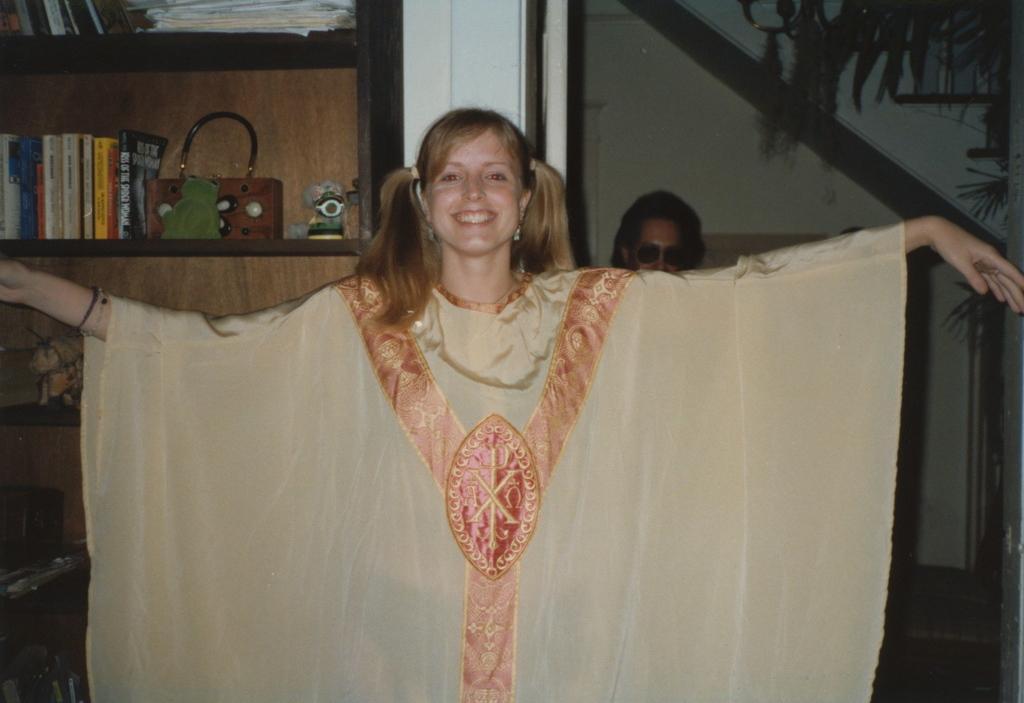Could you give a brief overview of what you see in this image? In this image, at the middle there is a girl standing and she is wearing a cream color dress, in the background there is a person standing, at the left side there is a rack and there are some books and a purse kept in a rack. 